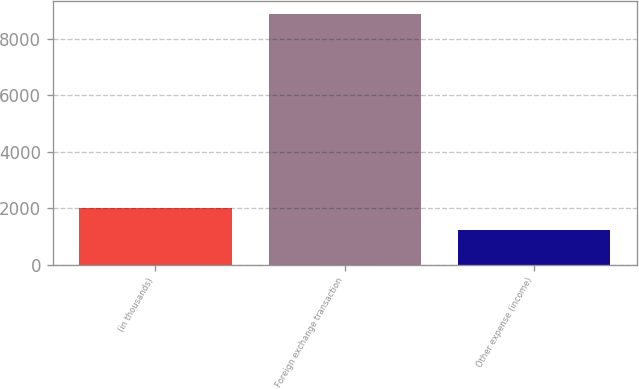Convert chart. <chart><loc_0><loc_0><loc_500><loc_500><bar_chart><fcel>(in thousands)<fcel>Foreign exchange transaction<fcel>Other expense (income)<nl><fcel>2008<fcel>8881<fcel>1229<nl></chart> 